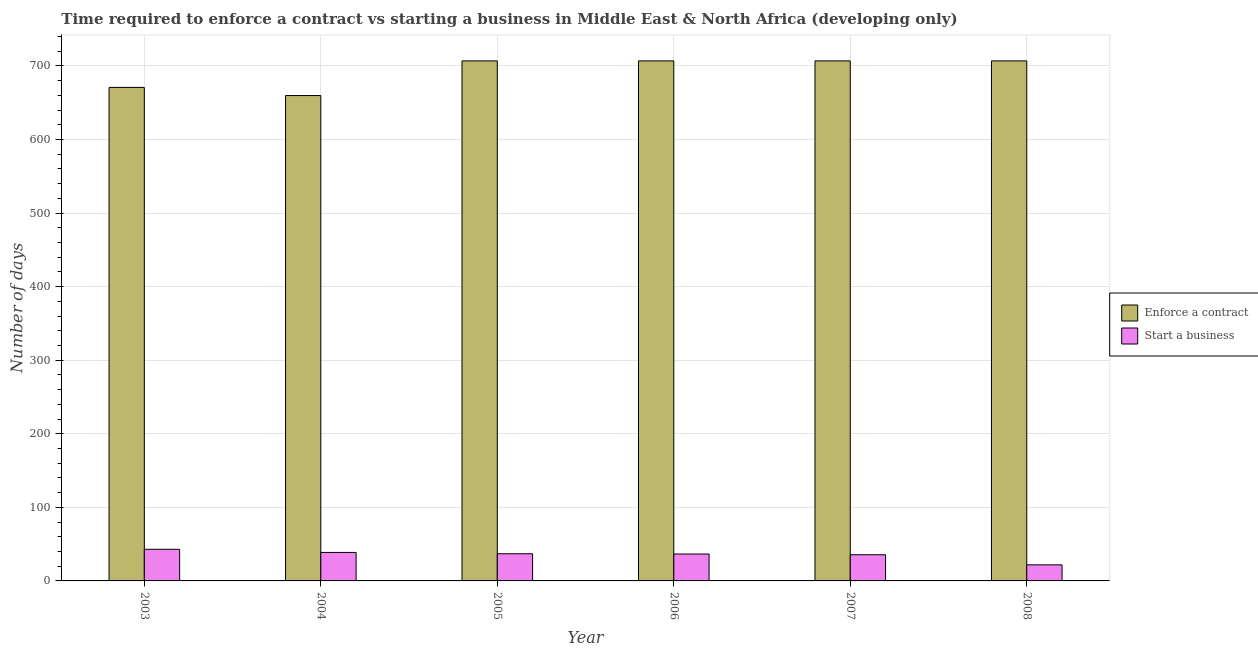How many different coloured bars are there?
Your answer should be very brief. 2. How many bars are there on the 4th tick from the left?
Your answer should be very brief. 2. How many bars are there on the 6th tick from the right?
Your answer should be compact. 2. What is the number of days to start a business in 2003?
Offer a terse response. 43. Across all years, what is the maximum number of days to enforece a contract?
Keep it short and to the point. 706.83. Across all years, what is the minimum number of days to enforece a contract?
Give a very brief answer. 659.73. In which year was the number of days to enforece a contract maximum?
Provide a succinct answer. 2005. In which year was the number of days to enforece a contract minimum?
Ensure brevity in your answer.  2004. What is the total number of days to enforece a contract in the graph?
Make the answer very short. 4157.84. What is the average number of days to enforece a contract per year?
Provide a short and direct response. 692.97. In the year 2008, what is the difference between the number of days to start a business and number of days to enforece a contract?
Provide a succinct answer. 0. In how many years, is the number of days to start a business greater than 120 days?
Ensure brevity in your answer.  0. What is the ratio of the number of days to start a business in 2004 to that in 2005?
Keep it short and to the point. 1.05. Is the difference between the number of days to enforece a contract in 2005 and 2006 greater than the difference between the number of days to start a business in 2005 and 2006?
Offer a very short reply. No. What is the difference between the highest and the second highest number of days to start a business?
Keep it short and to the point. 4.27. What is the difference between the highest and the lowest number of days to enforece a contract?
Offer a terse response. 47.11. In how many years, is the number of days to start a business greater than the average number of days to start a business taken over all years?
Keep it short and to the point. 5. What does the 1st bar from the left in 2003 represents?
Your response must be concise. Enforce a contract. What does the 1st bar from the right in 2007 represents?
Your answer should be compact. Start a business. Are all the bars in the graph horizontal?
Your response must be concise. No. How many years are there in the graph?
Your answer should be compact. 6. What is the difference between two consecutive major ticks on the Y-axis?
Your answer should be very brief. 100. Does the graph contain any zero values?
Your answer should be compact. No. Does the graph contain grids?
Make the answer very short. Yes. Where does the legend appear in the graph?
Make the answer very short. Center right. How many legend labels are there?
Your answer should be very brief. 2. What is the title of the graph?
Your answer should be very brief. Time required to enforce a contract vs starting a business in Middle East & North Africa (developing only). What is the label or title of the Y-axis?
Provide a short and direct response. Number of days. What is the Number of days of Enforce a contract in 2003?
Provide a short and direct response. 670.78. What is the Number of days in Enforce a contract in 2004?
Ensure brevity in your answer.  659.73. What is the Number of days of Start a business in 2004?
Give a very brief answer. 38.73. What is the Number of days of Enforce a contract in 2005?
Ensure brevity in your answer.  706.83. What is the Number of days of Start a business in 2005?
Your answer should be very brief. 36.92. What is the Number of days of Enforce a contract in 2006?
Your answer should be compact. 706.83. What is the Number of days of Start a business in 2006?
Make the answer very short. 36.58. What is the Number of days of Enforce a contract in 2007?
Offer a terse response. 706.83. What is the Number of days of Start a business in 2007?
Your answer should be compact. 35.58. What is the Number of days of Enforce a contract in 2008?
Offer a very short reply. 706.83. What is the Number of days of Start a business in 2008?
Provide a short and direct response. 21.83. Across all years, what is the maximum Number of days in Enforce a contract?
Your answer should be very brief. 706.83. Across all years, what is the maximum Number of days in Start a business?
Provide a succinct answer. 43. Across all years, what is the minimum Number of days in Enforce a contract?
Your answer should be very brief. 659.73. Across all years, what is the minimum Number of days of Start a business?
Make the answer very short. 21.83. What is the total Number of days in Enforce a contract in the graph?
Your answer should be very brief. 4157.84. What is the total Number of days in Start a business in the graph?
Offer a very short reply. 212.64. What is the difference between the Number of days of Enforce a contract in 2003 and that in 2004?
Offer a terse response. 11.05. What is the difference between the Number of days in Start a business in 2003 and that in 2004?
Offer a terse response. 4.27. What is the difference between the Number of days in Enforce a contract in 2003 and that in 2005?
Give a very brief answer. -36.06. What is the difference between the Number of days in Start a business in 2003 and that in 2005?
Your response must be concise. 6.08. What is the difference between the Number of days in Enforce a contract in 2003 and that in 2006?
Provide a succinct answer. -36.06. What is the difference between the Number of days in Start a business in 2003 and that in 2006?
Keep it short and to the point. 6.42. What is the difference between the Number of days of Enforce a contract in 2003 and that in 2007?
Provide a short and direct response. -36.06. What is the difference between the Number of days of Start a business in 2003 and that in 2007?
Provide a succinct answer. 7.42. What is the difference between the Number of days of Enforce a contract in 2003 and that in 2008?
Your response must be concise. -36.06. What is the difference between the Number of days of Start a business in 2003 and that in 2008?
Provide a short and direct response. 21.17. What is the difference between the Number of days in Enforce a contract in 2004 and that in 2005?
Give a very brief answer. -47.11. What is the difference between the Number of days in Start a business in 2004 and that in 2005?
Provide a succinct answer. 1.81. What is the difference between the Number of days in Enforce a contract in 2004 and that in 2006?
Ensure brevity in your answer.  -47.11. What is the difference between the Number of days in Start a business in 2004 and that in 2006?
Offer a terse response. 2.14. What is the difference between the Number of days of Enforce a contract in 2004 and that in 2007?
Keep it short and to the point. -47.11. What is the difference between the Number of days in Start a business in 2004 and that in 2007?
Your answer should be very brief. 3.14. What is the difference between the Number of days in Enforce a contract in 2004 and that in 2008?
Provide a succinct answer. -47.11. What is the difference between the Number of days in Start a business in 2004 and that in 2008?
Offer a very short reply. 16.89. What is the difference between the Number of days in Start a business in 2005 and that in 2006?
Make the answer very short. 0.33. What is the difference between the Number of days of Enforce a contract in 2005 and that in 2007?
Your answer should be very brief. 0. What is the difference between the Number of days in Start a business in 2005 and that in 2007?
Your answer should be compact. 1.33. What is the difference between the Number of days of Start a business in 2005 and that in 2008?
Your response must be concise. 15.08. What is the difference between the Number of days of Enforce a contract in 2006 and that in 2007?
Your answer should be compact. 0. What is the difference between the Number of days of Start a business in 2006 and that in 2007?
Make the answer very short. 1. What is the difference between the Number of days of Start a business in 2006 and that in 2008?
Keep it short and to the point. 14.75. What is the difference between the Number of days of Start a business in 2007 and that in 2008?
Provide a short and direct response. 13.75. What is the difference between the Number of days of Enforce a contract in 2003 and the Number of days of Start a business in 2004?
Provide a succinct answer. 632.05. What is the difference between the Number of days in Enforce a contract in 2003 and the Number of days in Start a business in 2005?
Your response must be concise. 633.86. What is the difference between the Number of days in Enforce a contract in 2003 and the Number of days in Start a business in 2006?
Ensure brevity in your answer.  634.19. What is the difference between the Number of days in Enforce a contract in 2003 and the Number of days in Start a business in 2007?
Provide a short and direct response. 635.19. What is the difference between the Number of days in Enforce a contract in 2003 and the Number of days in Start a business in 2008?
Keep it short and to the point. 648.94. What is the difference between the Number of days of Enforce a contract in 2004 and the Number of days of Start a business in 2005?
Keep it short and to the point. 622.81. What is the difference between the Number of days in Enforce a contract in 2004 and the Number of days in Start a business in 2006?
Provide a succinct answer. 623.14. What is the difference between the Number of days in Enforce a contract in 2004 and the Number of days in Start a business in 2007?
Give a very brief answer. 624.14. What is the difference between the Number of days in Enforce a contract in 2004 and the Number of days in Start a business in 2008?
Your answer should be very brief. 637.89. What is the difference between the Number of days in Enforce a contract in 2005 and the Number of days in Start a business in 2006?
Provide a short and direct response. 670.25. What is the difference between the Number of days in Enforce a contract in 2005 and the Number of days in Start a business in 2007?
Provide a succinct answer. 671.25. What is the difference between the Number of days of Enforce a contract in 2005 and the Number of days of Start a business in 2008?
Your response must be concise. 685. What is the difference between the Number of days of Enforce a contract in 2006 and the Number of days of Start a business in 2007?
Ensure brevity in your answer.  671.25. What is the difference between the Number of days of Enforce a contract in 2006 and the Number of days of Start a business in 2008?
Keep it short and to the point. 685. What is the difference between the Number of days in Enforce a contract in 2007 and the Number of days in Start a business in 2008?
Your response must be concise. 685. What is the average Number of days in Enforce a contract per year?
Keep it short and to the point. 692.97. What is the average Number of days in Start a business per year?
Provide a succinct answer. 35.44. In the year 2003, what is the difference between the Number of days in Enforce a contract and Number of days in Start a business?
Provide a short and direct response. 627.78. In the year 2004, what is the difference between the Number of days in Enforce a contract and Number of days in Start a business?
Give a very brief answer. 621. In the year 2005, what is the difference between the Number of days of Enforce a contract and Number of days of Start a business?
Give a very brief answer. 669.92. In the year 2006, what is the difference between the Number of days of Enforce a contract and Number of days of Start a business?
Give a very brief answer. 670.25. In the year 2007, what is the difference between the Number of days in Enforce a contract and Number of days in Start a business?
Offer a terse response. 671.25. In the year 2008, what is the difference between the Number of days in Enforce a contract and Number of days in Start a business?
Give a very brief answer. 685. What is the ratio of the Number of days of Enforce a contract in 2003 to that in 2004?
Ensure brevity in your answer.  1.02. What is the ratio of the Number of days in Start a business in 2003 to that in 2004?
Offer a terse response. 1.11. What is the ratio of the Number of days of Enforce a contract in 2003 to that in 2005?
Ensure brevity in your answer.  0.95. What is the ratio of the Number of days in Start a business in 2003 to that in 2005?
Your answer should be compact. 1.16. What is the ratio of the Number of days in Enforce a contract in 2003 to that in 2006?
Your answer should be compact. 0.95. What is the ratio of the Number of days in Start a business in 2003 to that in 2006?
Give a very brief answer. 1.18. What is the ratio of the Number of days of Enforce a contract in 2003 to that in 2007?
Your answer should be compact. 0.95. What is the ratio of the Number of days in Start a business in 2003 to that in 2007?
Keep it short and to the point. 1.21. What is the ratio of the Number of days in Enforce a contract in 2003 to that in 2008?
Your answer should be very brief. 0.95. What is the ratio of the Number of days in Start a business in 2003 to that in 2008?
Offer a very short reply. 1.97. What is the ratio of the Number of days of Enforce a contract in 2004 to that in 2005?
Ensure brevity in your answer.  0.93. What is the ratio of the Number of days in Start a business in 2004 to that in 2005?
Provide a short and direct response. 1.05. What is the ratio of the Number of days of Enforce a contract in 2004 to that in 2006?
Your response must be concise. 0.93. What is the ratio of the Number of days in Start a business in 2004 to that in 2006?
Ensure brevity in your answer.  1.06. What is the ratio of the Number of days in Enforce a contract in 2004 to that in 2007?
Keep it short and to the point. 0.93. What is the ratio of the Number of days of Start a business in 2004 to that in 2007?
Provide a succinct answer. 1.09. What is the ratio of the Number of days of Enforce a contract in 2004 to that in 2008?
Offer a very short reply. 0.93. What is the ratio of the Number of days in Start a business in 2004 to that in 2008?
Ensure brevity in your answer.  1.77. What is the ratio of the Number of days in Enforce a contract in 2005 to that in 2006?
Make the answer very short. 1. What is the ratio of the Number of days in Start a business in 2005 to that in 2006?
Offer a terse response. 1.01. What is the ratio of the Number of days in Start a business in 2005 to that in 2007?
Provide a short and direct response. 1.04. What is the ratio of the Number of days of Enforce a contract in 2005 to that in 2008?
Your answer should be very brief. 1. What is the ratio of the Number of days of Start a business in 2005 to that in 2008?
Provide a succinct answer. 1.69. What is the ratio of the Number of days of Enforce a contract in 2006 to that in 2007?
Offer a very short reply. 1. What is the ratio of the Number of days in Start a business in 2006 to that in 2007?
Offer a very short reply. 1.03. What is the ratio of the Number of days in Start a business in 2006 to that in 2008?
Offer a very short reply. 1.68. What is the ratio of the Number of days of Enforce a contract in 2007 to that in 2008?
Your response must be concise. 1. What is the ratio of the Number of days in Start a business in 2007 to that in 2008?
Keep it short and to the point. 1.63. What is the difference between the highest and the second highest Number of days in Enforce a contract?
Your response must be concise. 0. What is the difference between the highest and the second highest Number of days of Start a business?
Your response must be concise. 4.27. What is the difference between the highest and the lowest Number of days in Enforce a contract?
Offer a terse response. 47.11. What is the difference between the highest and the lowest Number of days of Start a business?
Give a very brief answer. 21.17. 